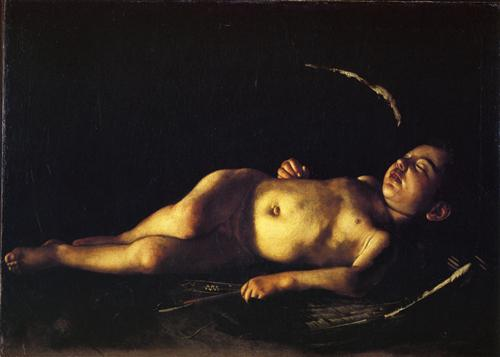Can you explain the significance of the lighting in this artwork? The lighting in this artwork plays a crucial role in setting the tone and mood of the scene. The light source is positioned in the top left corner, casting a gentle and soft glow on the boy's face and torso. This creates a stark contrast with the dark background, drawing the viewer's attention to the central figure and emphasizing his peaceful slumber. The interplay of light and shadow enhances the sense of depth and realism in the painting, making the boy appear almost lifelike. Furthermore, the use of light symbolizes purity and innocence, highlighting the tranquil nature of the boy's repose. Why do you think the artist chose to include minimal elements in the painting? The artist's choice to include minimal elements in the painting likely serves to focus the viewer's attention on the central figure – the young boy. By eliminating distractions and keeping the composition simple, the artist underscores the poignant and serene nature of the scene. This minimalistic approach allows the viewer to appreciate the delicate details and nuances of the boy's peaceful repose. Moreover, the simplicity of the objects – a boy, a bench, a pillow, and a cloth – emphasizes the purity and innocence of childhood, adding depth and emotional resonance to the artwork. 